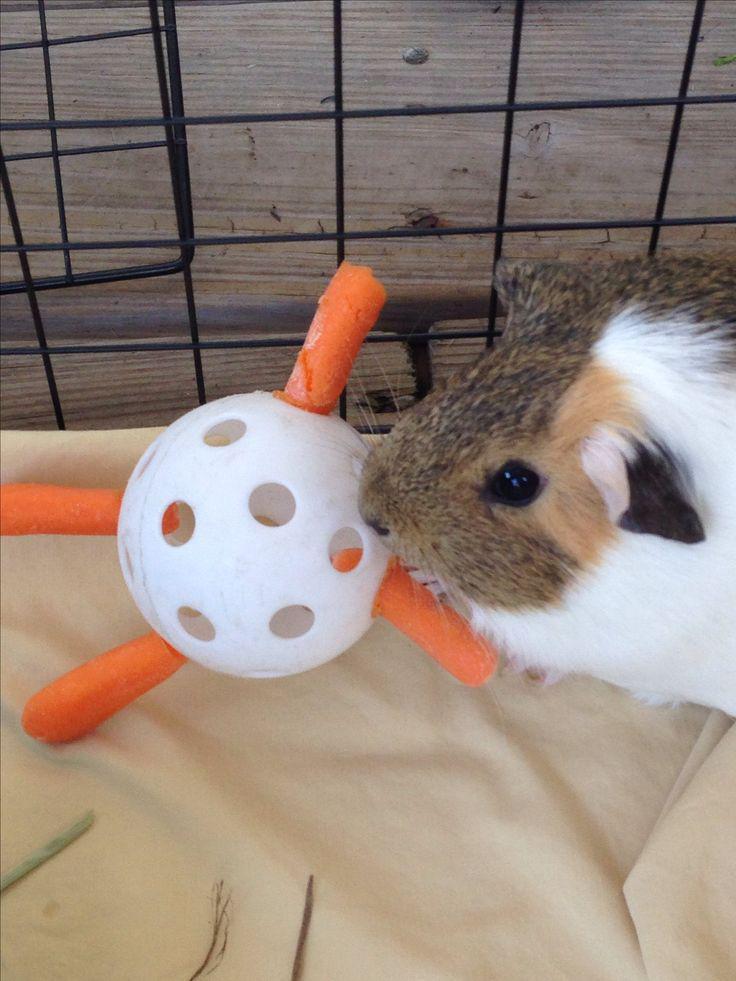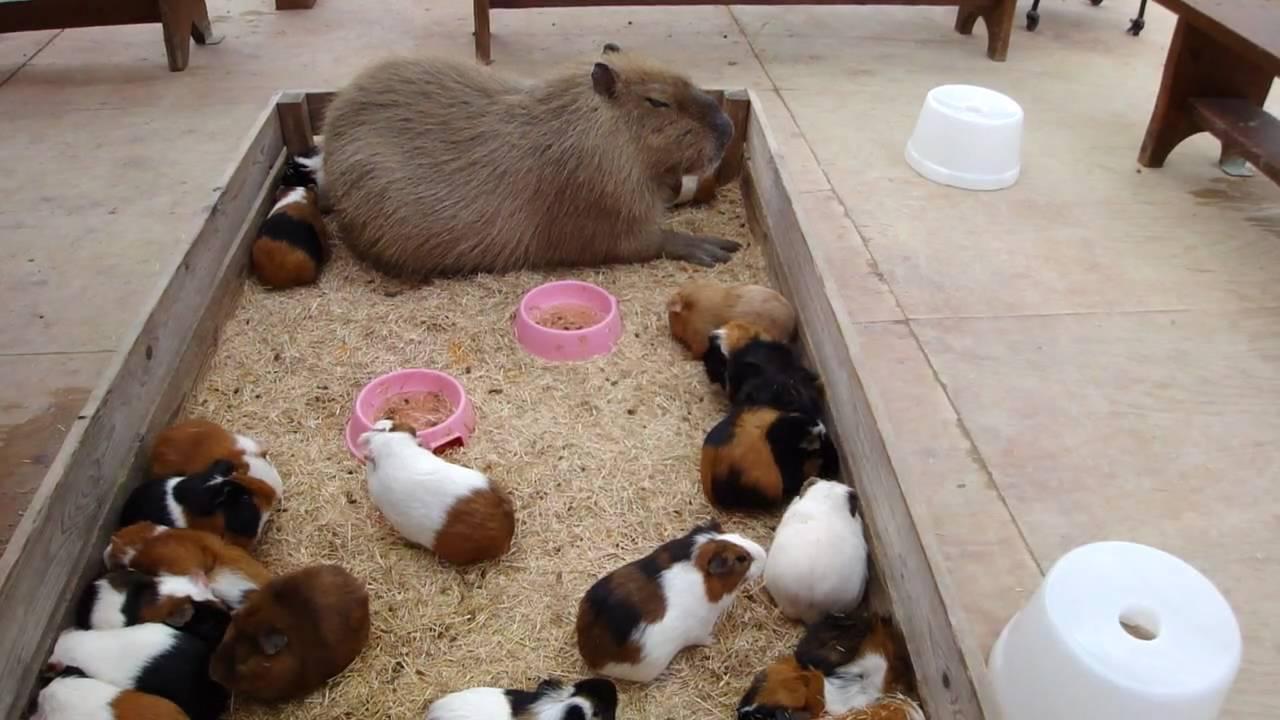The first image is the image on the left, the second image is the image on the right. Examine the images to the left and right. Is the description "The animal in one of the images is in a wire cage." accurate? Answer yes or no. Yes. 